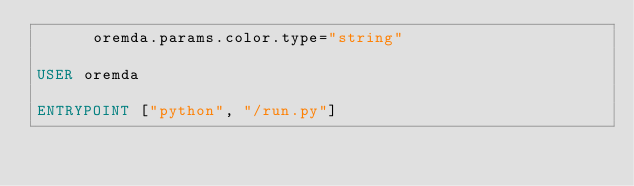Convert code to text. <code><loc_0><loc_0><loc_500><loc_500><_Dockerfile_>      oremda.params.color.type="string"

USER oremda

ENTRYPOINT ["python", "/run.py"]
</code> 